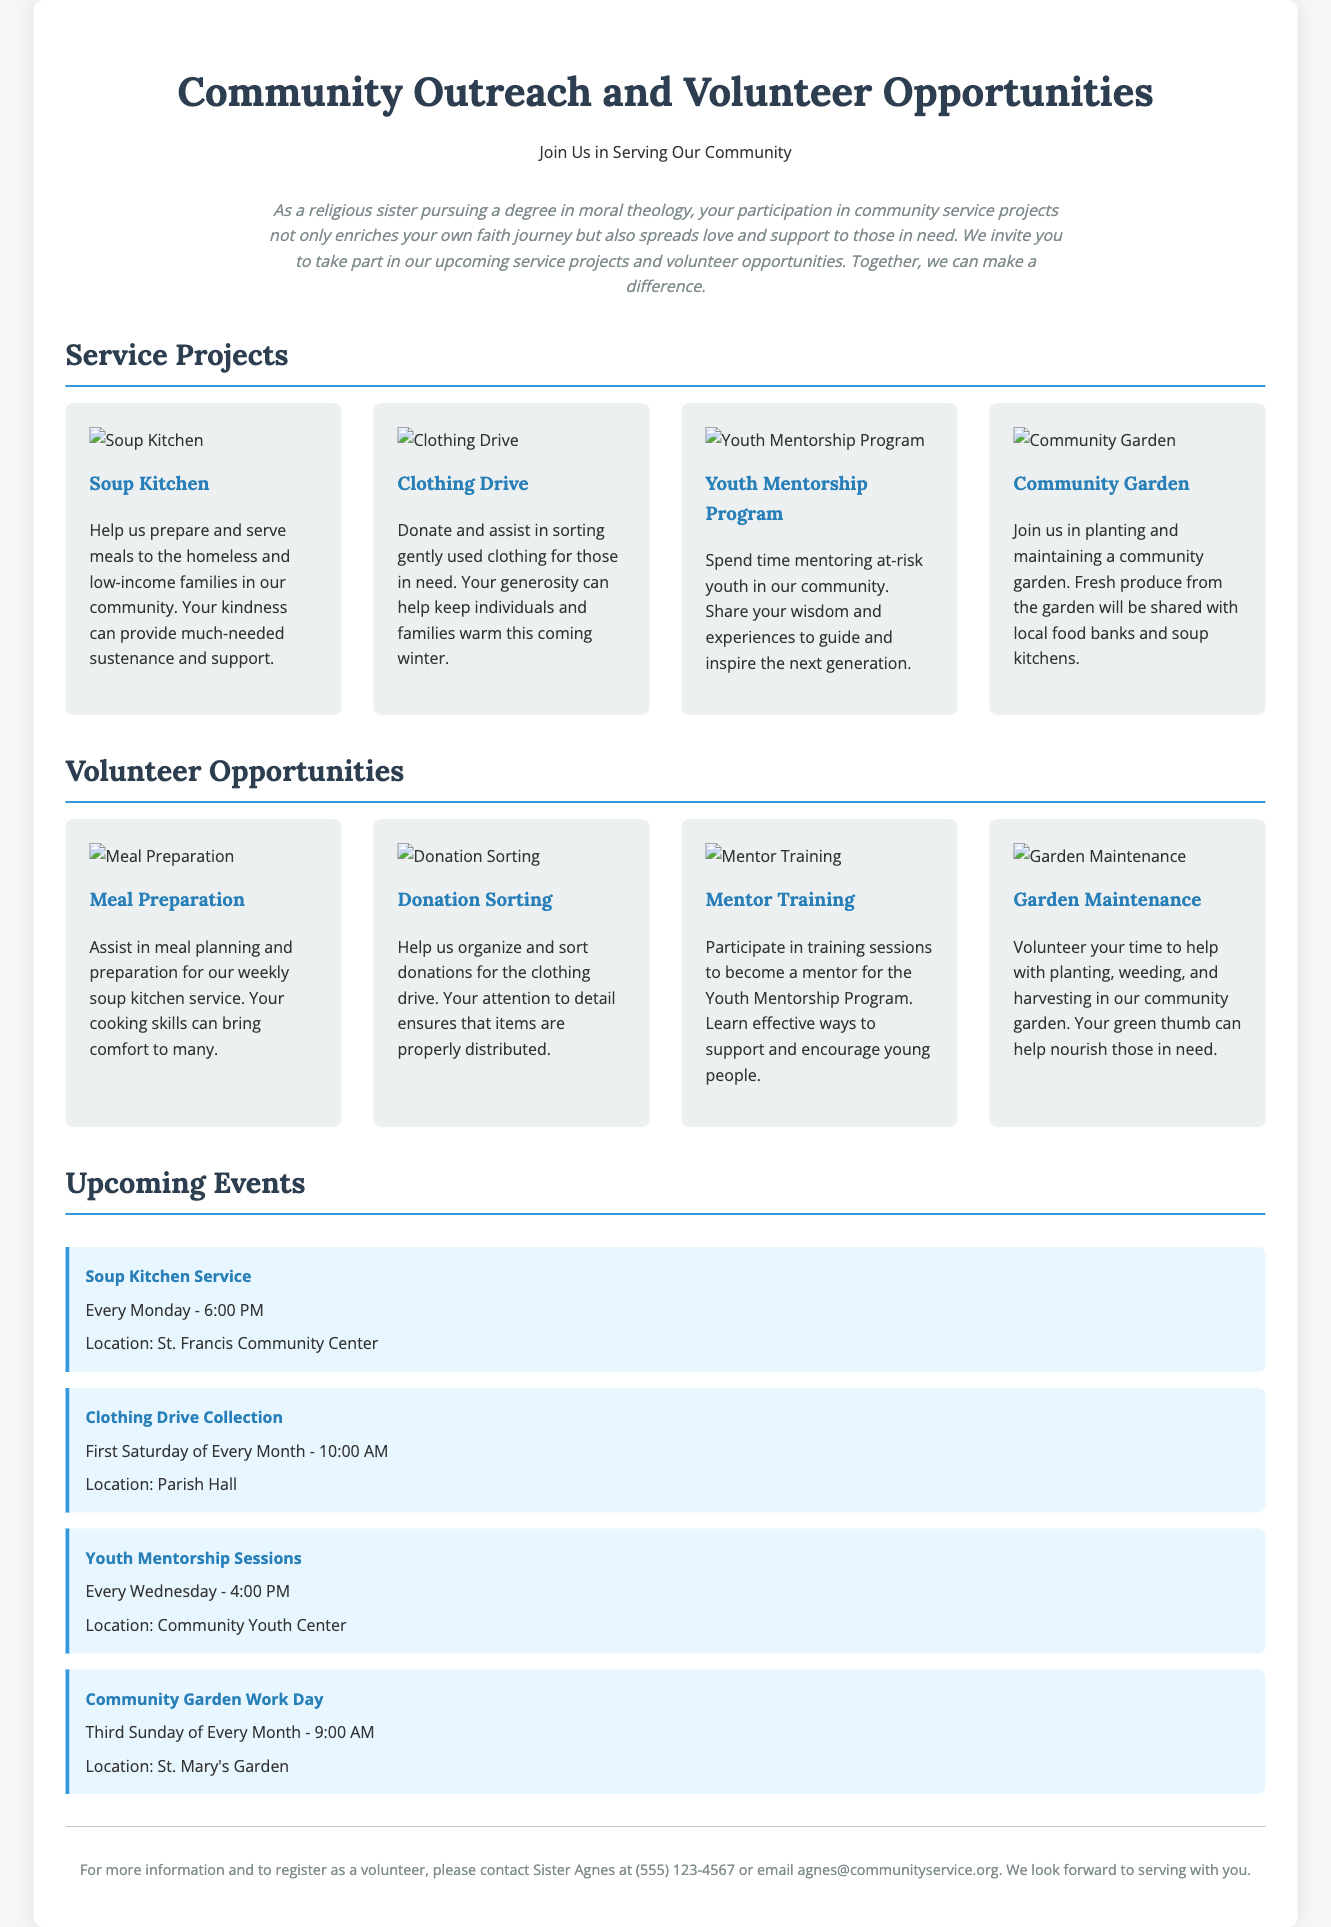What is the title of the document? The title of the document is stated in the header section.
Answer: Community Outreach and Volunteer Opportunities Who can you contact for more information? The document provides contact information for Sister Agnes.
Answer: Sister Agnes How often is the Soup Kitchen Service held? The scheduling of the Soup Kitchen Service is mentioned in the upcoming events section.
Answer: Every Monday What is the location of the Clothing Drive Collection? The location for the Clothing Drive Collection is specified in the calendar events.
Answer: Parish Hall Which service project involves helping at-risk youth? The service projects list includes mentoring to help at-risk youth.
Answer: Youth Mentorship Program What color is used for the cards in the document? The color used for the background of the service project cards is mentioned in the styling.
Answer: Light gray Which day of the month is the Community Garden Work Day scheduled? The calendar specifies that the Community Garden Work Day occurs on the third Sunday.
Answer: Third Sunday What kind of support does the Youth Mentorship Program provide? The document describes the purpose of the Youth Mentorship Program.
Answer: Mentoring How should you register as a volunteer? The footer provides details on how to register as a volunteer.
Answer: Contact Sister Agnes 